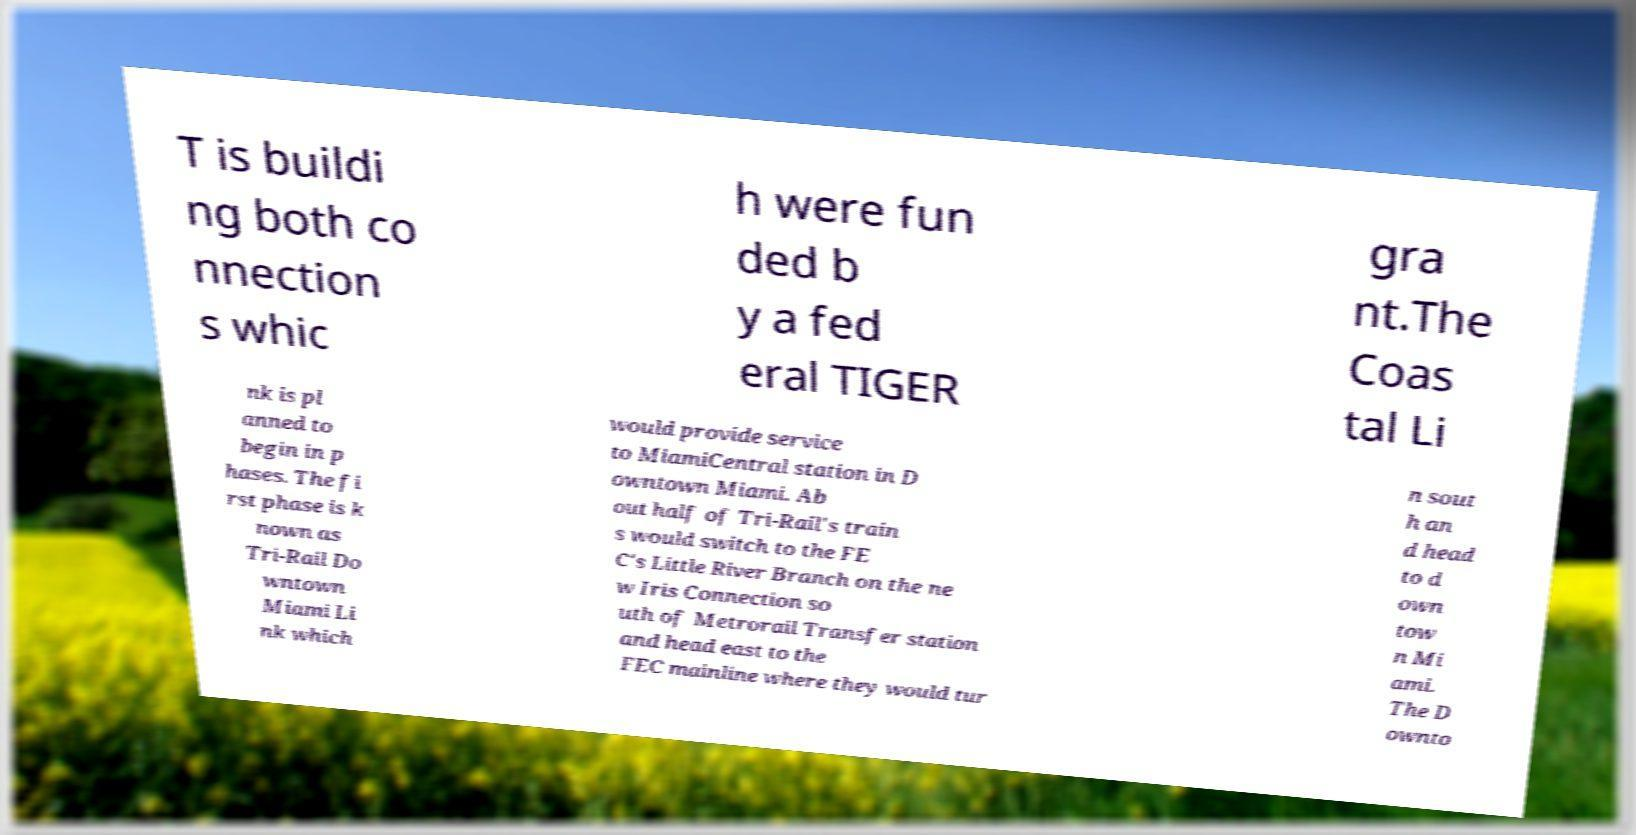Please identify and transcribe the text found in this image. T is buildi ng both co nnection s whic h were fun ded b y a fed eral TIGER gra nt.The Coas tal Li nk is pl anned to begin in p hases. The fi rst phase is k nown as Tri-Rail Do wntown Miami Li nk which would provide service to MiamiCentral station in D owntown Miami. Ab out half of Tri-Rail's train s would switch to the FE C's Little River Branch on the ne w Iris Connection so uth of Metrorail Transfer station and head east to the FEC mainline where they would tur n sout h an d head to d own tow n Mi ami. The D ownto 